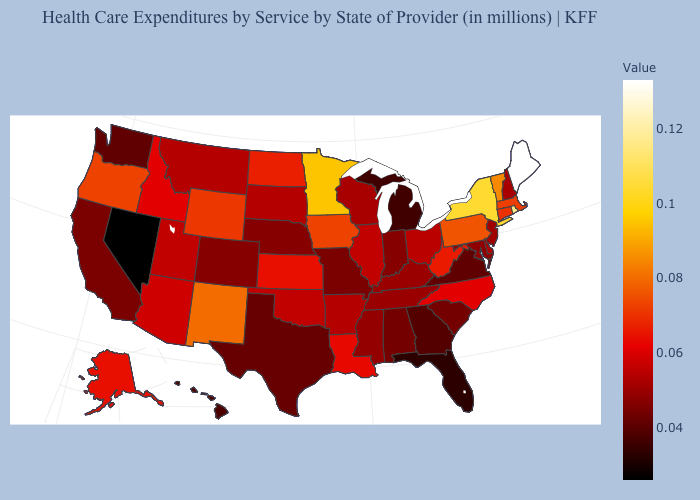Among the states that border Iowa , which have the highest value?
Give a very brief answer. Minnesota. Is the legend a continuous bar?
Short answer required. Yes. Among the states that border Delaware , does New Jersey have the lowest value?
Answer briefly. No. 